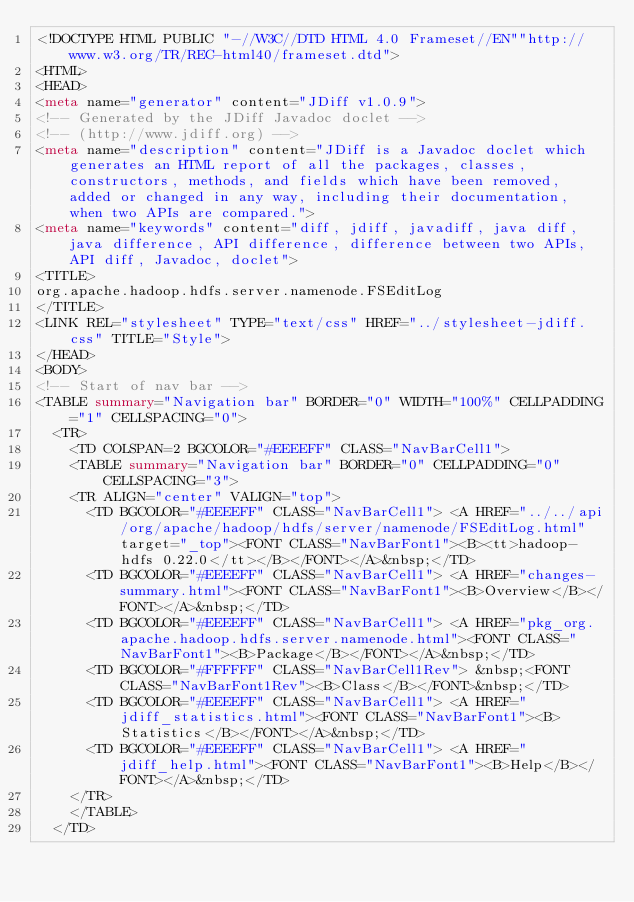Convert code to text. <code><loc_0><loc_0><loc_500><loc_500><_HTML_><!DOCTYPE HTML PUBLIC "-//W3C//DTD HTML 4.0 Frameset//EN""http://www.w3.org/TR/REC-html40/frameset.dtd">
<HTML>
<HEAD>
<meta name="generator" content="JDiff v1.0.9">
<!-- Generated by the JDiff Javadoc doclet -->
<!-- (http://www.jdiff.org) -->
<meta name="description" content="JDiff is a Javadoc doclet which generates an HTML report of all the packages, classes, constructors, methods, and fields which have been removed, added or changed in any way, including their documentation, when two APIs are compared.">
<meta name="keywords" content="diff, jdiff, javadiff, java diff, java difference, API difference, difference between two APIs, API diff, Javadoc, doclet">
<TITLE>
org.apache.hadoop.hdfs.server.namenode.FSEditLog
</TITLE>
<LINK REL="stylesheet" TYPE="text/css" HREF="../stylesheet-jdiff.css" TITLE="Style">
</HEAD>
<BODY>
<!-- Start of nav bar -->
<TABLE summary="Navigation bar" BORDER="0" WIDTH="100%" CELLPADDING="1" CELLSPACING="0">
  <TR>
    <TD COLSPAN=2 BGCOLOR="#EEEEFF" CLASS="NavBarCell1">
    <TABLE summary="Navigation bar" BORDER="0" CELLPADDING="0" CELLSPACING="3">
    <TR ALIGN="center" VALIGN="top">
      <TD BGCOLOR="#EEEEFF" CLASS="NavBarCell1"> <A HREF="../../api/org/apache/hadoop/hdfs/server/namenode/FSEditLog.html" target="_top"><FONT CLASS="NavBarFont1"><B><tt>hadoop-hdfs 0.22.0</tt></B></FONT></A>&nbsp;</TD>
      <TD BGCOLOR="#EEEEFF" CLASS="NavBarCell1"> <A HREF="changes-summary.html"><FONT CLASS="NavBarFont1"><B>Overview</B></FONT></A>&nbsp;</TD>
      <TD BGCOLOR="#EEEEFF" CLASS="NavBarCell1"> <A HREF="pkg_org.apache.hadoop.hdfs.server.namenode.html"><FONT CLASS="NavBarFont1"><B>Package</B></FONT></A>&nbsp;</TD>
      <TD BGCOLOR="#FFFFFF" CLASS="NavBarCell1Rev"> &nbsp;<FONT CLASS="NavBarFont1Rev"><B>Class</B></FONT>&nbsp;</TD>
      <TD BGCOLOR="#EEEEFF" CLASS="NavBarCell1"> <A HREF="jdiff_statistics.html"><FONT CLASS="NavBarFont1"><B>Statistics</B></FONT></A>&nbsp;</TD>
      <TD BGCOLOR="#EEEEFF" CLASS="NavBarCell1"> <A HREF="jdiff_help.html"><FONT CLASS="NavBarFont1"><B>Help</B></FONT></A>&nbsp;</TD>
    </TR>
    </TABLE>
  </TD></code> 